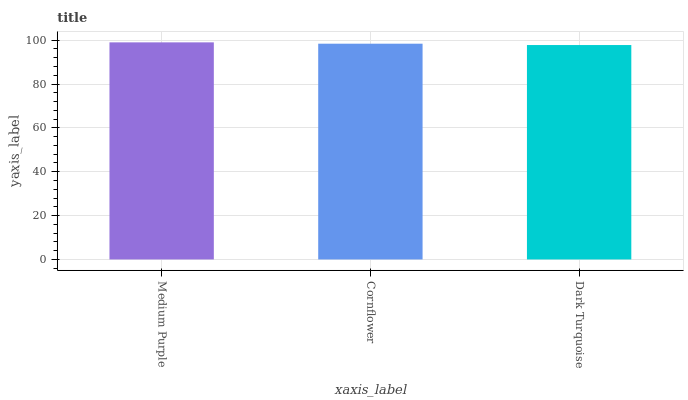Is Dark Turquoise the minimum?
Answer yes or no. Yes. Is Medium Purple the maximum?
Answer yes or no. Yes. Is Cornflower the minimum?
Answer yes or no. No. Is Cornflower the maximum?
Answer yes or no. No. Is Medium Purple greater than Cornflower?
Answer yes or no. Yes. Is Cornflower less than Medium Purple?
Answer yes or no. Yes. Is Cornflower greater than Medium Purple?
Answer yes or no. No. Is Medium Purple less than Cornflower?
Answer yes or no. No. Is Cornflower the high median?
Answer yes or no. Yes. Is Cornflower the low median?
Answer yes or no. Yes. Is Dark Turquoise the high median?
Answer yes or no. No. Is Medium Purple the low median?
Answer yes or no. No. 